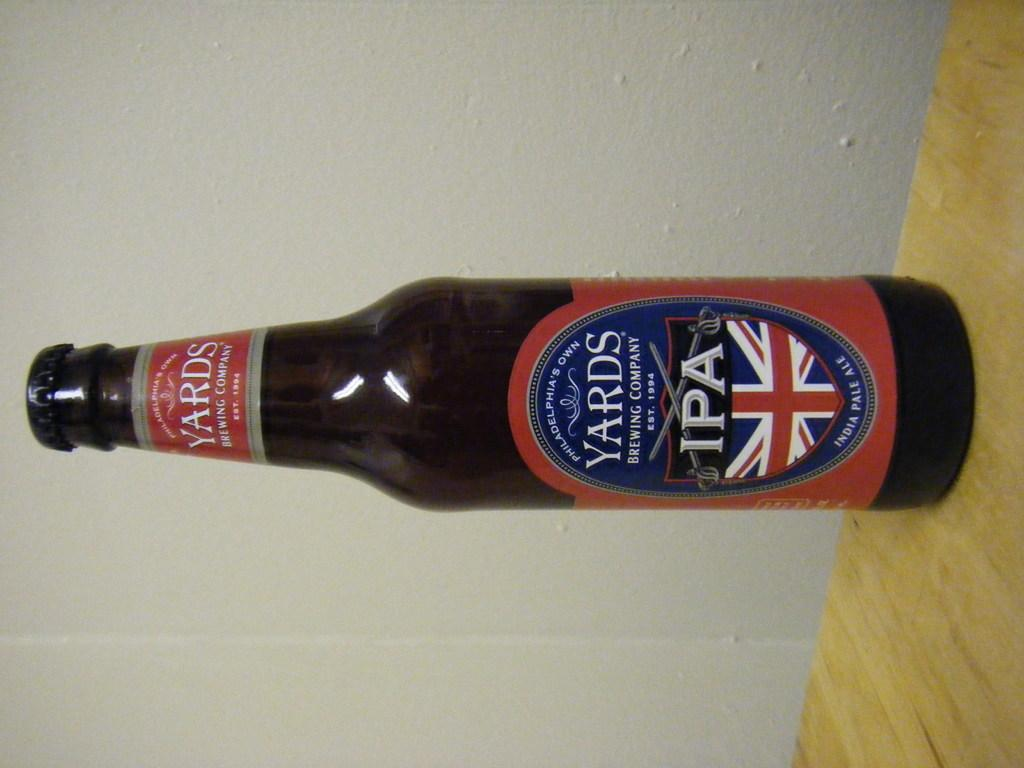<image>
Give a short and clear explanation of the subsequent image. Beer Bottle from Philadelphia's Own Brewing Company by the company Yards. 